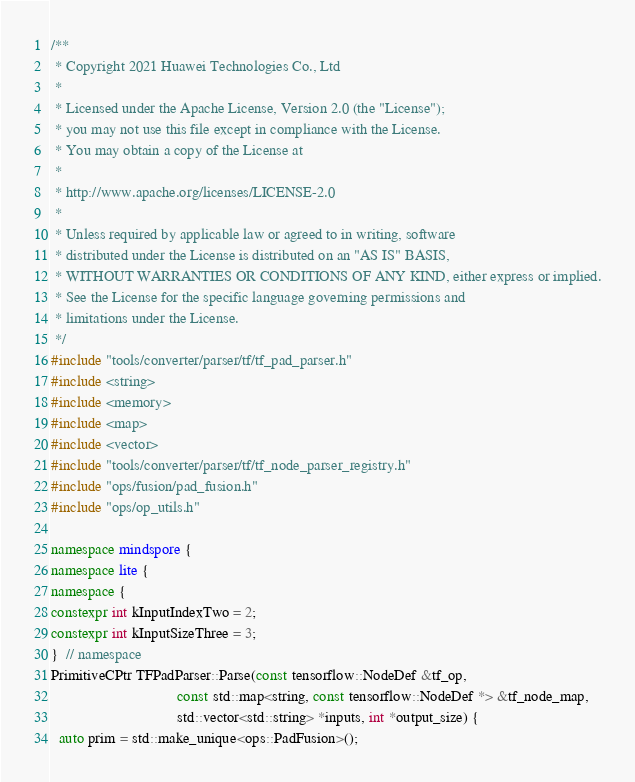<code> <loc_0><loc_0><loc_500><loc_500><_C++_>/**
 * Copyright 2021 Huawei Technologies Co., Ltd
 *
 * Licensed under the Apache License, Version 2.0 (the "License");
 * you may not use this file except in compliance with the License.
 * You may obtain a copy of the License at
 *
 * http://www.apache.org/licenses/LICENSE-2.0
 *
 * Unless required by applicable law or agreed to in writing, software
 * distributed under the License is distributed on an "AS IS" BASIS,
 * WITHOUT WARRANTIES OR CONDITIONS OF ANY KIND, either express or implied.
 * See the License for the specific language governing permissions and
 * limitations under the License.
 */
#include "tools/converter/parser/tf/tf_pad_parser.h"
#include <string>
#include <memory>
#include <map>
#include <vector>
#include "tools/converter/parser/tf/tf_node_parser_registry.h"
#include "ops/fusion/pad_fusion.h"
#include "ops/op_utils.h"

namespace mindspore {
namespace lite {
namespace {
constexpr int kInputIndexTwo = 2;
constexpr int kInputSizeThree = 3;
}  // namespace
PrimitiveCPtr TFPadParser::Parse(const tensorflow::NodeDef &tf_op,
                                 const std::map<string, const tensorflow::NodeDef *> &tf_node_map,
                                 std::vector<std::string> *inputs, int *output_size) {
  auto prim = std::make_unique<ops::PadFusion>();</code> 